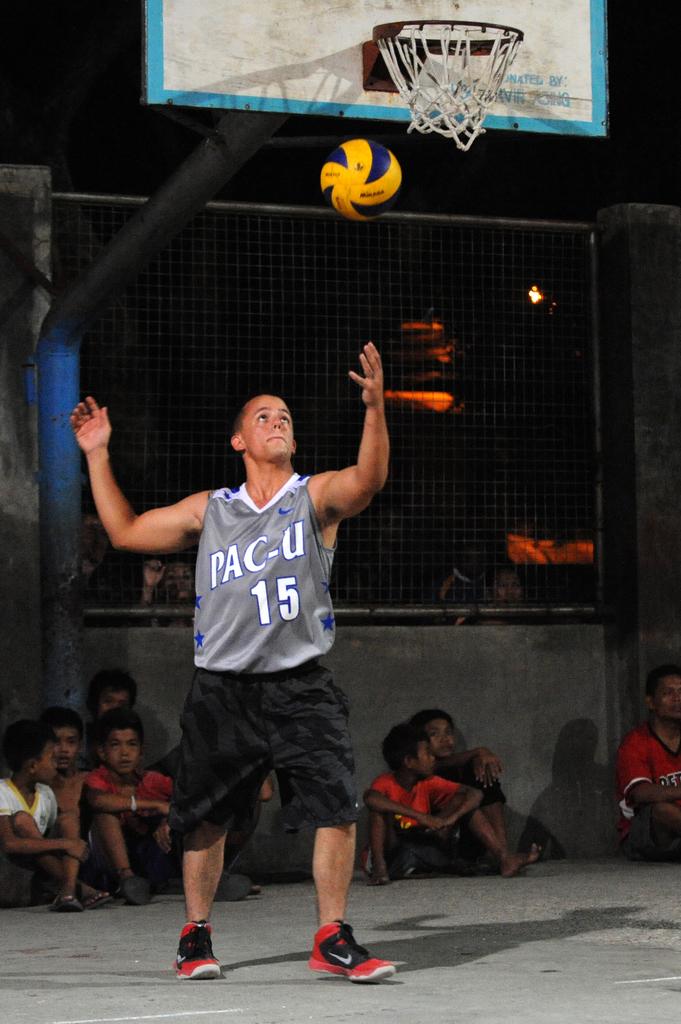What number is on his jersey?
Your answer should be compact. 15. 